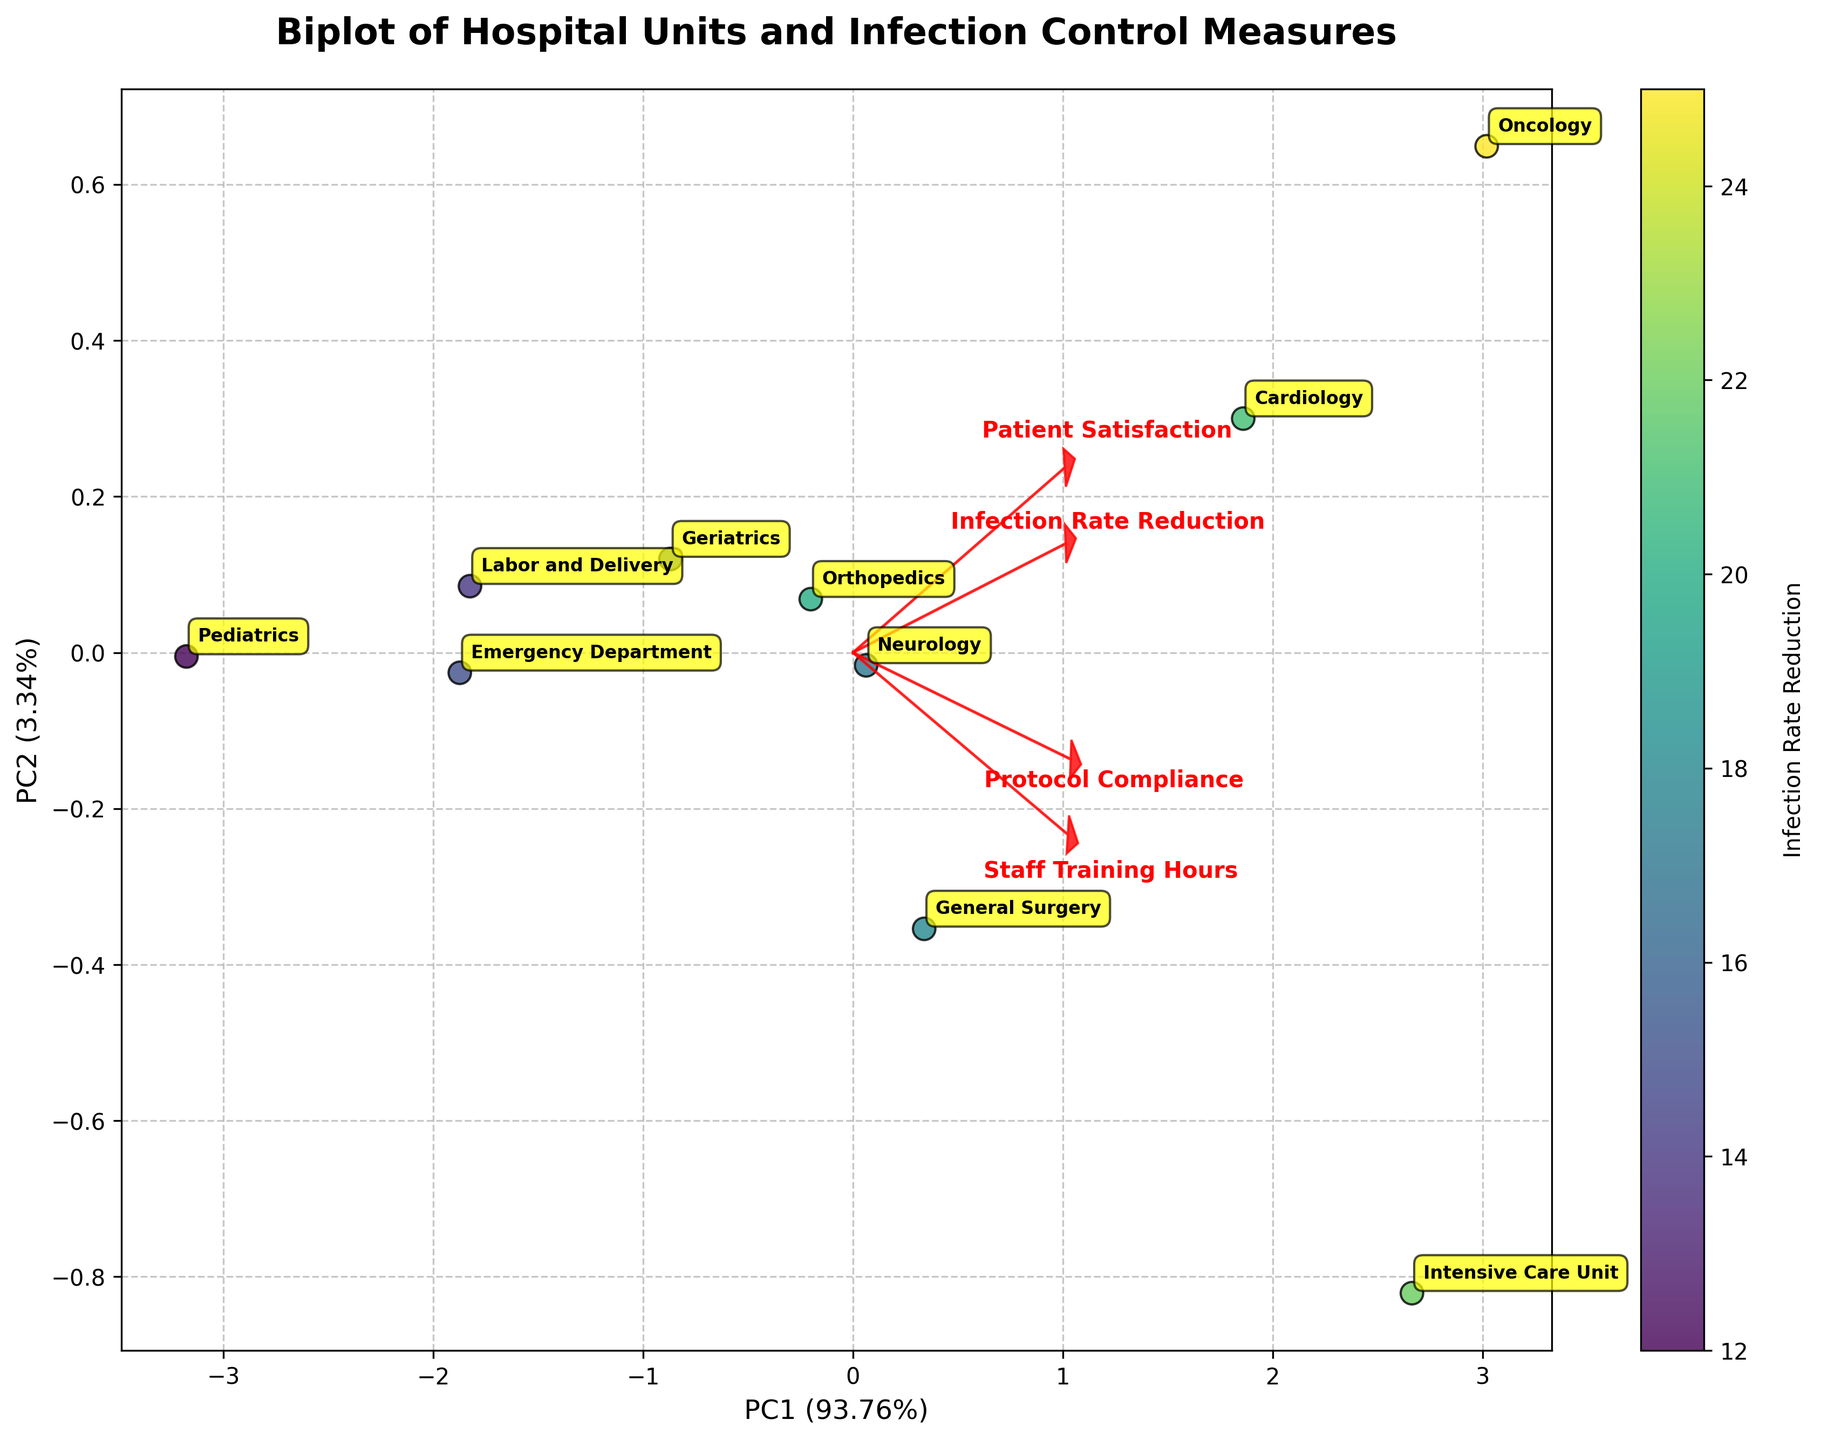What's the title of the biplot? Look at the top center of the figure where the title is displayed.
Answer: Biplot of Hospital Units and Infection Control Measures How many principal components are represented in the biplot? Observe the X and Y axes labels; each represents a principal component.
Answer: Two Which unit has the highest infection rate reduction? Refer to the color bar and find the unit with the highest position on the color gradient scale.
Answer: Oncology Which feature has the highest loading on PC1? Look at the arrows in the biplot and determine which feature's arrow extends furthest along the PC1 axis.
Answer: Protocol Compliance Compare General Surgery and Cardiology: Which unit has higher patient satisfaction? Locate General Surgery and Cardiology data points in the biplot and check their positions relative to the arrows for 'Patient Satisfaction'.
Answer: Cardiology Which feature contributes most to PC2? Examine the arrows and see which feature points most prominently towards the PC2 axis.
Answer: Staff Training Hours How does protocol compliance relate to infection rate reduction? Notice the direction and length of the 'Protocol Compliance' arrow in relation to the color gradient of the points representing infection rate reduction.
Answer: Directly correlated Combining Pediatrics and Intensive Care Unit, which unit requires the most staff training hours and has higher protocol compliance? Compare both units by checking their relative positions to the 'Staff Training Hours' and 'Protocol Compliance' arrows.
Answer: Intensive Care Unit Which units are clustered closely together in terms of infection rate reduction and staff training hours? Look for clusters of points in the biplot and check their proximity to the infection rate reduction color gradient and 'Staff Training Hours' arrow.
Answer: General Surgery and Neurology 